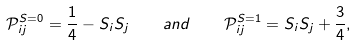Convert formula to latex. <formula><loc_0><loc_0><loc_500><loc_500>\mathcal { P } _ { i j } ^ { S = 0 } = \frac { 1 } { 4 } - { S } _ { i } { S } _ { j } \quad a n d \quad \mathcal { P } _ { i j } ^ { S = 1 } = { S } _ { i } { S } _ { j } + \frac { 3 } { 4 } ,</formula> 